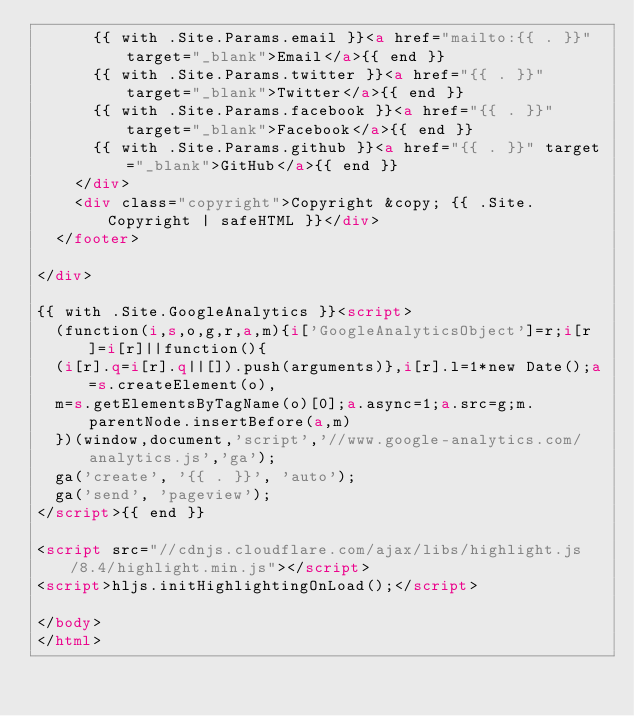<code> <loc_0><loc_0><loc_500><loc_500><_HTML_>			{{ with .Site.Params.email }}<a href="mailto:{{ . }}" target="_blank">Email</a>{{ end }}
			{{ with .Site.Params.twitter }}<a href="{{ . }}" target="_blank">Twitter</a>{{ end }}
			{{ with .Site.Params.facebook }}<a href="{{ . }}" target="_blank">Facebook</a>{{ end }}
			{{ with .Site.Params.github }}<a href="{{ . }}" target="_blank">GitHub</a>{{ end }}
		</div>
		<div class="copyright">Copyright &copy; {{ .Site.Copyright | safeHTML }}</div>
	</footer>

</div>

{{ with .Site.GoogleAnalytics }}<script>
	(function(i,s,o,g,r,a,m){i['GoogleAnalyticsObject']=r;i[r]=i[r]||function(){
	(i[r].q=i[r].q||[]).push(arguments)},i[r].l=1*new Date();a=s.createElement(o),
	m=s.getElementsByTagName(o)[0];a.async=1;a.src=g;m.parentNode.insertBefore(a,m)
	})(window,document,'script','//www.google-analytics.com/analytics.js','ga');
	ga('create', '{{ . }}', 'auto');
	ga('send', 'pageview');
</script>{{ end }}

<script src="//cdnjs.cloudflare.com/ajax/libs/highlight.js/8.4/highlight.min.js"></script>
<script>hljs.initHighlightingOnLoad();</script>

</body>
</html>
</code> 